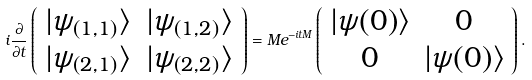Convert formula to latex. <formula><loc_0><loc_0><loc_500><loc_500>i \frac { \partial } { \partial t } \left ( \begin{array} { c c c c c c } | \psi _ { ( 1 , 1 ) } \rangle & | \psi _ { ( 1 , 2 ) } \rangle \\ | \psi _ { ( 2 , 1 ) } \rangle & | \psi _ { ( 2 , 2 ) } \rangle \\ \end{array} \right ) = M e ^ { - i t M } \left ( \begin{array} { c c c c c c } | \psi ( 0 ) \rangle & 0 \\ 0 & | \psi ( 0 ) \rangle \\ \end{array} \right ) .</formula> 